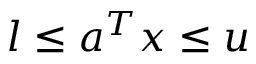<formula> <loc_0><loc_0><loc_500><loc_500>l \leq a ^ { T } x \leq u</formula> 